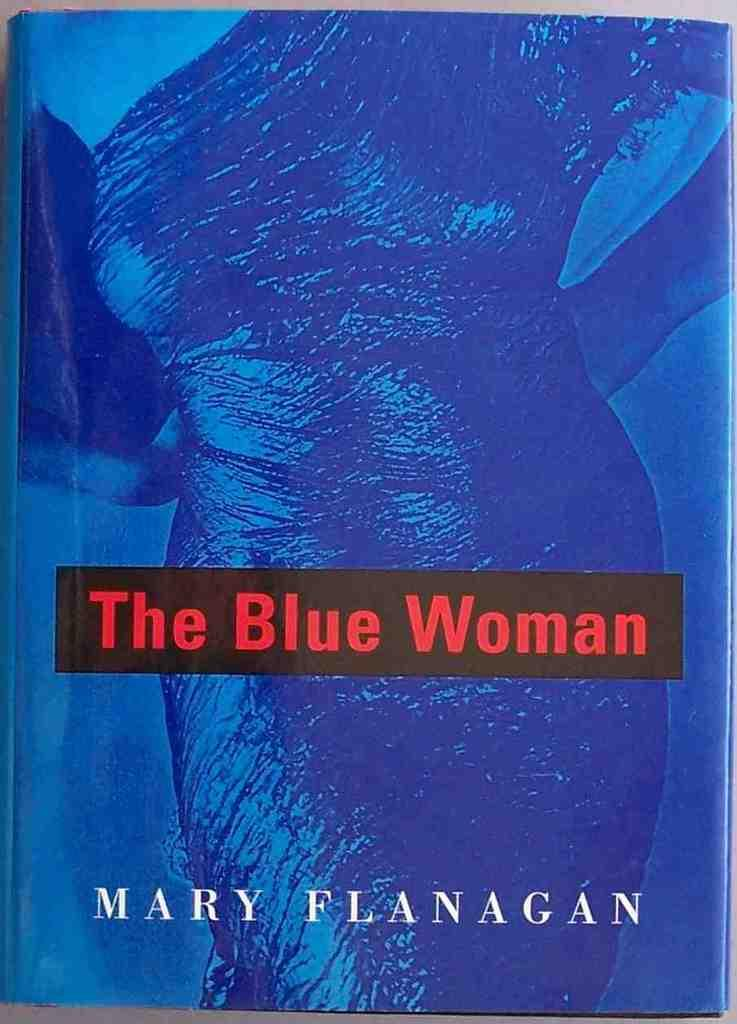Provide a one-sentence caption for the provided image. The book cover of The Blue Woman shows a woman wearing a dress. 